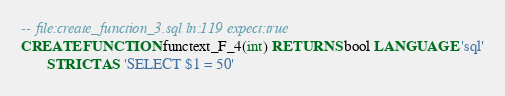<code> <loc_0><loc_0><loc_500><loc_500><_SQL_>-- file:create_function_3.sql ln:119 expect:true
CREATE FUNCTION functext_F_4(int) RETURNS bool LANGUAGE 'sql'
       STRICT AS 'SELECT $1 = 50'
</code> 